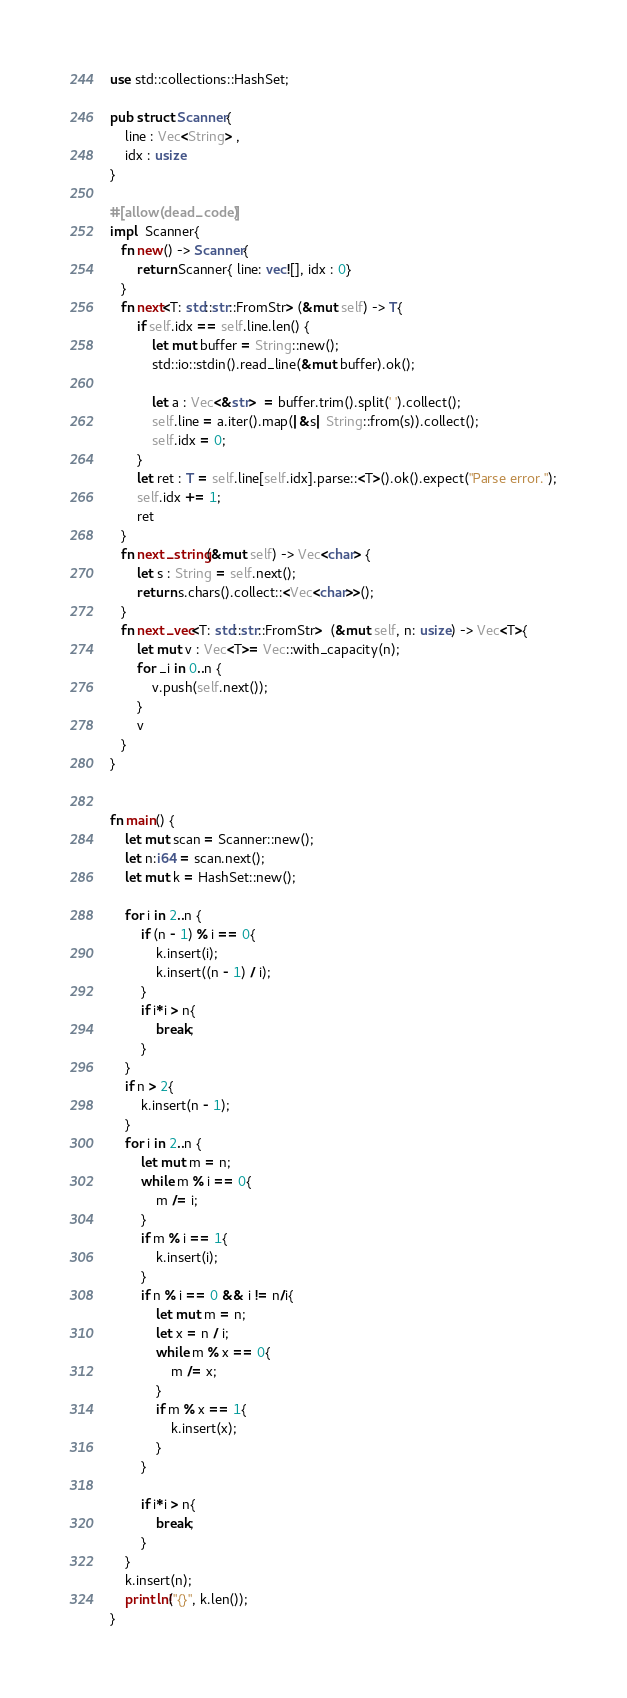Convert code to text. <code><loc_0><loc_0><loc_500><loc_500><_Rust_>use std::collections::HashSet;

pub struct Scanner{
    line : Vec<String> ,
    idx : usize
}

#[allow(dead_code)]
impl  Scanner{
   fn new() -> Scanner{
       return Scanner{ line: vec![], idx : 0}
   }
   fn next<T: std::str::FromStr> (&mut self) -> T{
       if self.idx == self.line.len() {
           let mut buffer = String::new();
           std::io::stdin().read_line(&mut buffer).ok();

           let a : Vec<&str>  = buffer.trim().split(' ').collect();
           self.line = a.iter().map(|&s| String::from(s)).collect();
           self.idx = 0;
       }
       let ret : T = self.line[self.idx].parse::<T>().ok().expect("Parse error.");
       self.idx += 1;
       ret
   }
   fn next_string(&mut self) -> Vec<char> {
       let s : String = self.next();
       return s.chars().collect::<Vec<char>>();
   }
   fn next_vec<T: std::str::FromStr>  (&mut self, n: usize) -> Vec<T>{
       let mut v : Vec<T>= Vec::with_capacity(n);
       for _i in 0..n {
           v.push(self.next());
       }
       v
   }
}


fn main() {
    let mut scan = Scanner::new();
    let n:i64 = scan.next();
    let mut k = HashSet::new();
    
    for i in 2..n {
        if (n - 1) % i == 0{
            k.insert(i);
            k.insert((n - 1) / i);
        }
        if i*i > n{
            break;
        }
    }
    if n > 2{
        k.insert(n - 1);
    }
    for i in 2..n {
        let mut m = n; 
        while m % i == 0{
            m /= i;
        }
        if m % i == 1{
            k.insert(i);
        }
        if n % i == 0 && i != n/i{
            let mut m = n;
            let x = n / i; 
            while m % x == 0{
                m /= x;
            }
            if m % x == 1{
                k.insert(x);
            }      
        }

        if i*i > n{
            break;
        }
    }
    k.insert(n);
    println!("{}", k.len());
}
</code> 